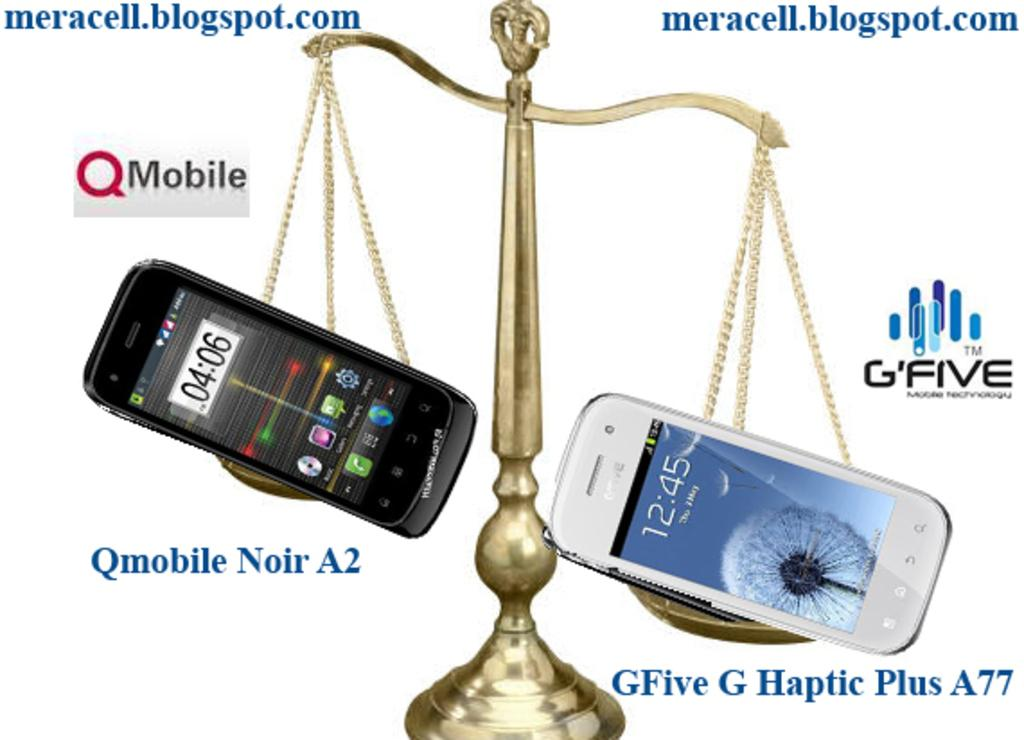<image>
Relay a brief, clear account of the picture shown. Two phones on a scale with one that says the time at 4:06. 